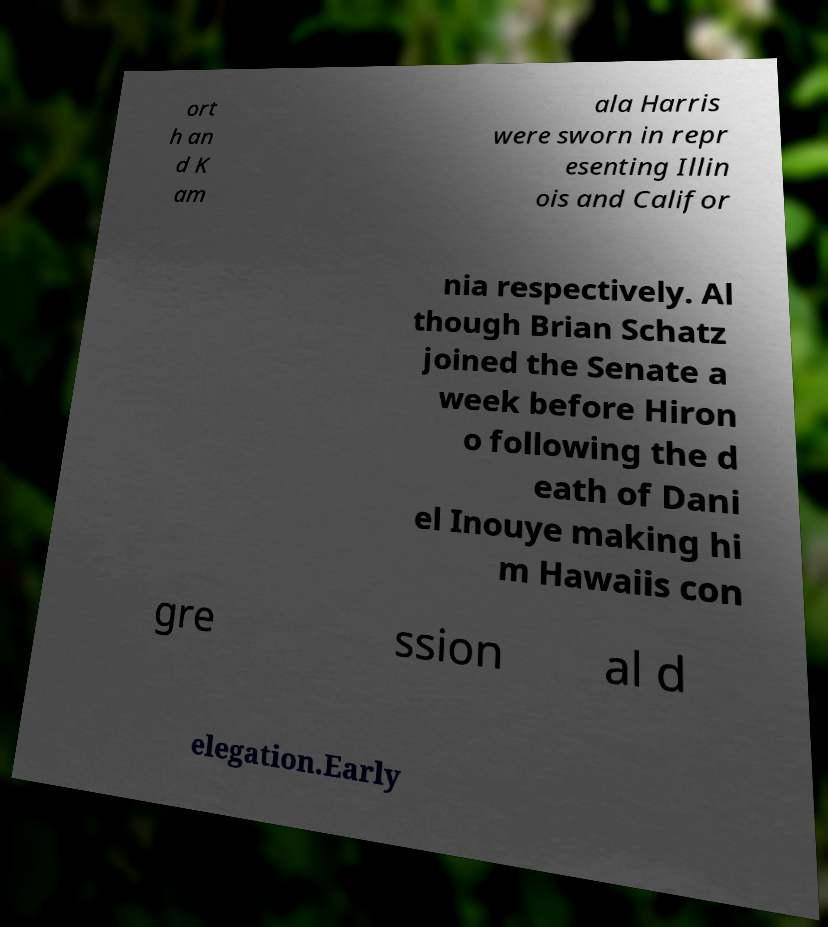For documentation purposes, I need the text within this image transcribed. Could you provide that? ort h an d K am ala Harris were sworn in repr esenting Illin ois and Califor nia respectively. Al though Brian Schatz joined the Senate a week before Hiron o following the d eath of Dani el Inouye making hi m Hawaiis con gre ssion al d elegation.Early 